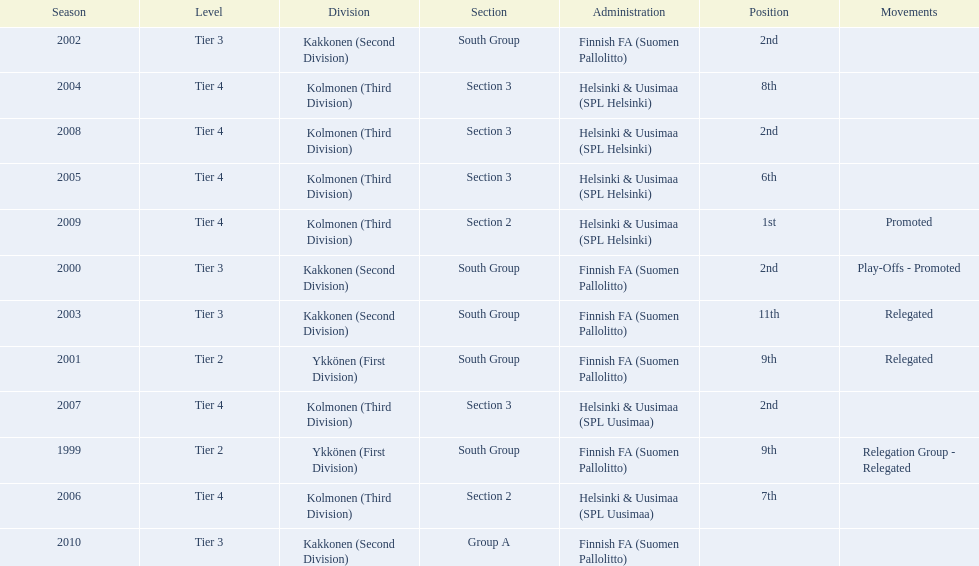What position did this team get after getting 9th place in 1999? 2nd. 